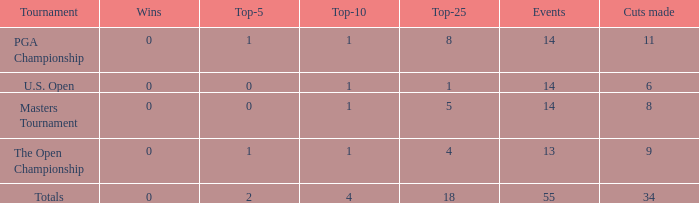What is the average top-5 when the cuts made is more than 34? None. 